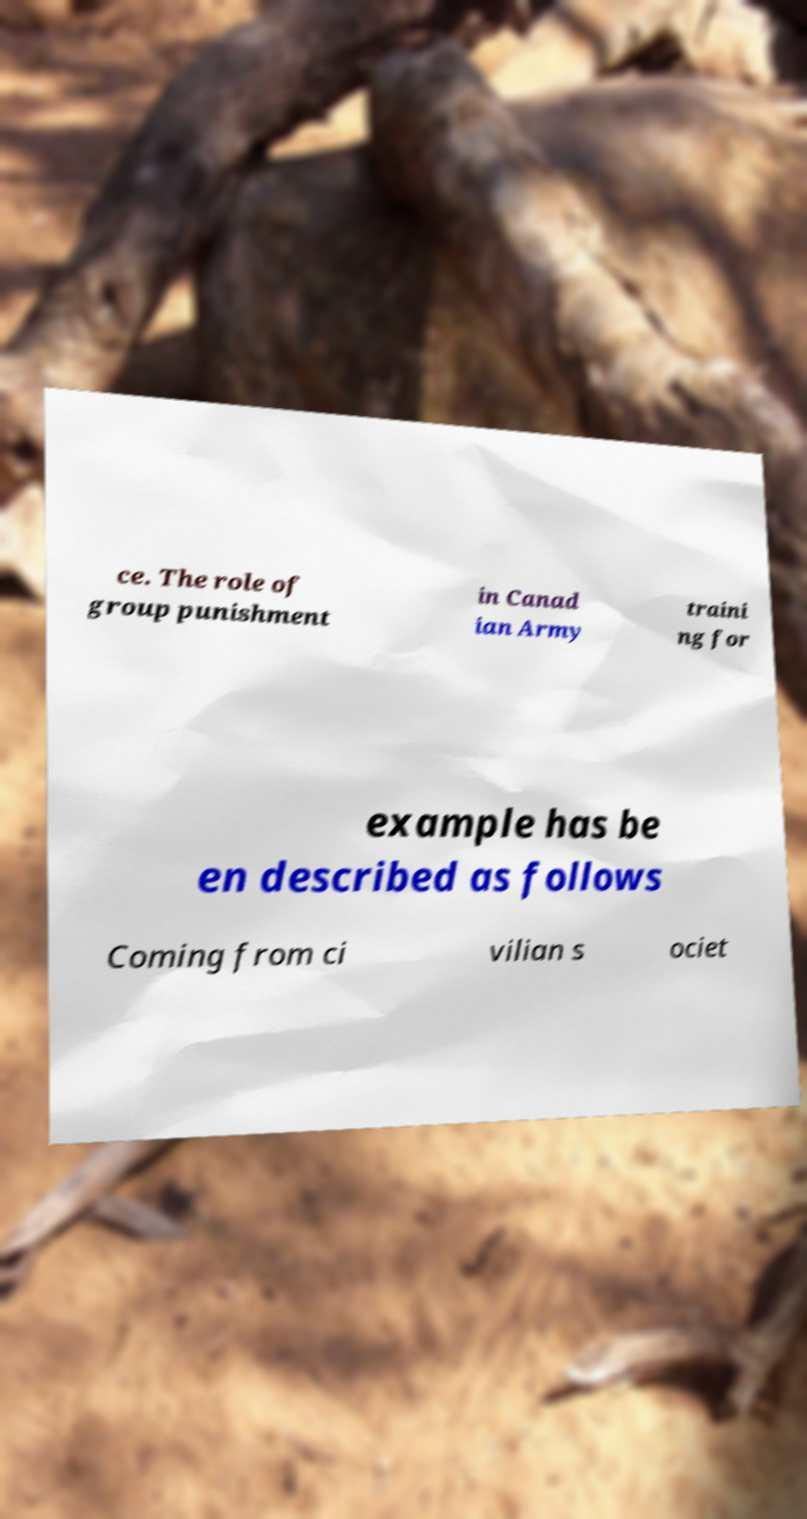For documentation purposes, I need the text within this image transcribed. Could you provide that? ce. The role of group punishment in Canad ian Army traini ng for example has be en described as follows Coming from ci vilian s ociet 